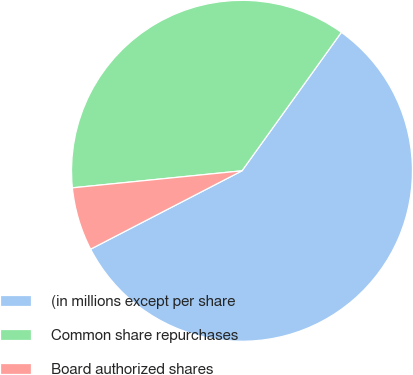<chart> <loc_0><loc_0><loc_500><loc_500><pie_chart><fcel>(in millions except per share<fcel>Common share repurchases<fcel>Board authorized shares<nl><fcel>57.49%<fcel>36.5%<fcel>6.01%<nl></chart> 